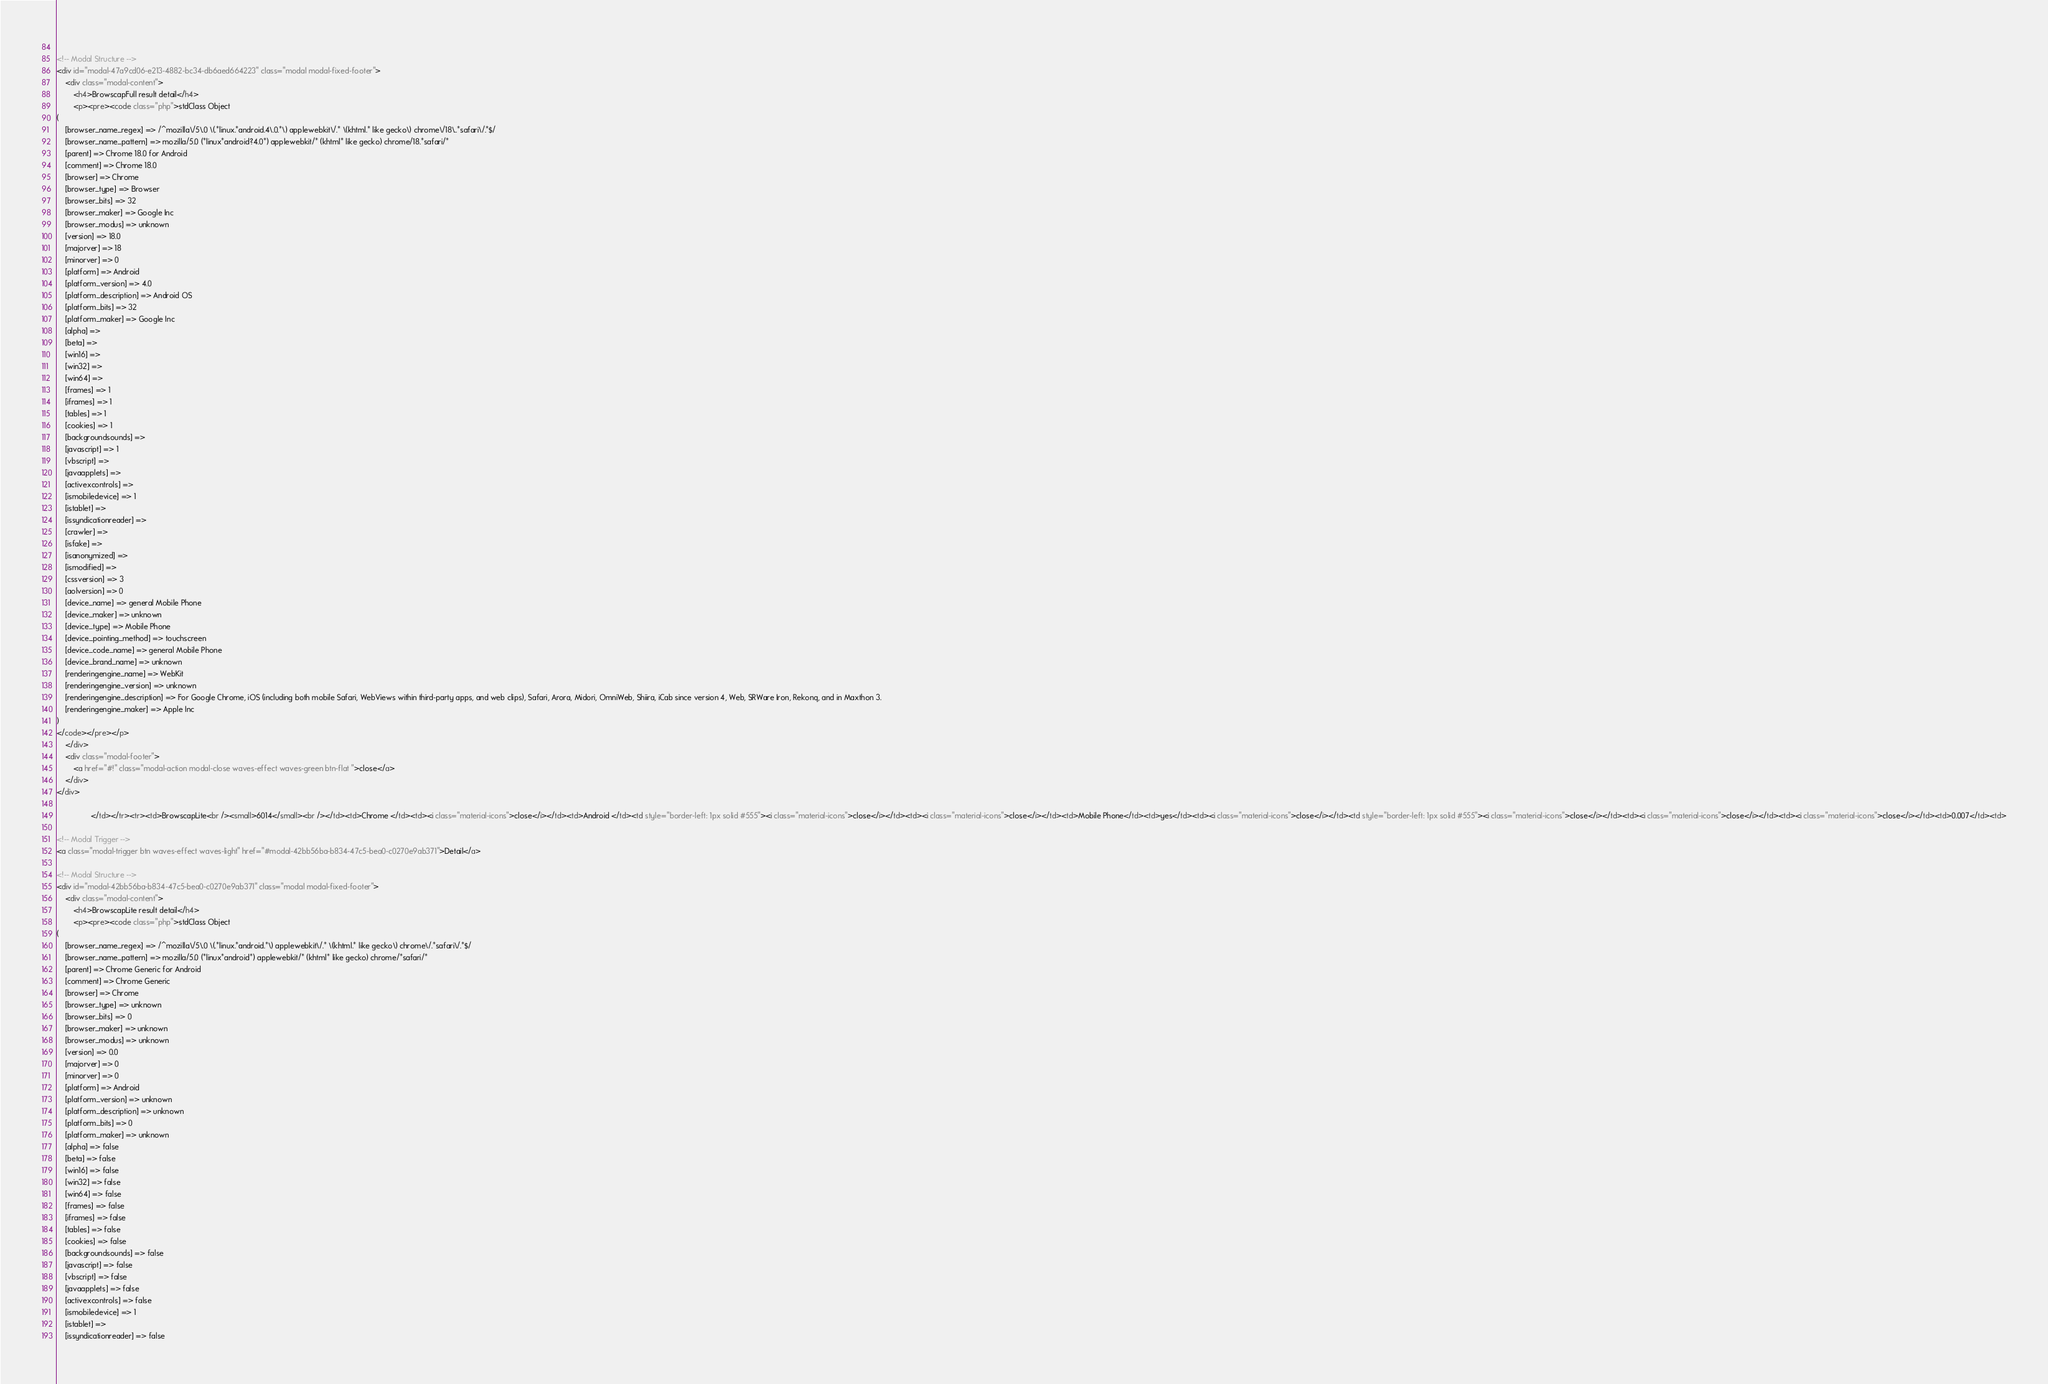<code> <loc_0><loc_0><loc_500><loc_500><_HTML_>        
<!-- Modal Structure -->
<div id="modal-47a9cd06-e213-4882-bc34-db6aed664223" class="modal modal-fixed-footer">
    <div class="modal-content">
        <h4>BrowscapFull result detail</h4>
        <p><pre><code class="php">stdClass Object
(
    [browser_name_regex] => /^mozilla\/5\.0 \(.*linux.*android.4\.0.*\) applewebkit\/.* \(khtml.* like gecko\) chrome\/18\..*safari\/.*$/
    [browser_name_pattern] => mozilla/5.0 (*linux*android?4.0*) applewebkit/* (khtml* like gecko) chrome/18.*safari/*
    [parent] => Chrome 18.0 for Android
    [comment] => Chrome 18.0
    [browser] => Chrome
    [browser_type] => Browser
    [browser_bits] => 32
    [browser_maker] => Google Inc
    [browser_modus] => unknown
    [version] => 18.0
    [majorver] => 18
    [minorver] => 0
    [platform] => Android
    [platform_version] => 4.0
    [platform_description] => Android OS
    [platform_bits] => 32
    [platform_maker] => Google Inc
    [alpha] => 
    [beta] => 
    [win16] => 
    [win32] => 
    [win64] => 
    [frames] => 1
    [iframes] => 1
    [tables] => 1
    [cookies] => 1
    [backgroundsounds] => 
    [javascript] => 1
    [vbscript] => 
    [javaapplets] => 
    [activexcontrols] => 
    [ismobiledevice] => 1
    [istablet] => 
    [issyndicationreader] => 
    [crawler] => 
    [isfake] => 
    [isanonymized] => 
    [ismodified] => 
    [cssversion] => 3
    [aolversion] => 0
    [device_name] => general Mobile Phone
    [device_maker] => unknown
    [device_type] => Mobile Phone
    [device_pointing_method] => touchscreen
    [device_code_name] => general Mobile Phone
    [device_brand_name] => unknown
    [renderingengine_name] => WebKit
    [renderingengine_version] => unknown
    [renderingengine_description] => For Google Chrome, iOS (including both mobile Safari, WebViews within third-party apps, and web clips), Safari, Arora, Midori, OmniWeb, Shiira, iCab since version 4, Web, SRWare Iron, Rekonq, and in Maxthon 3.
    [renderingengine_maker] => Apple Inc
)
</code></pre></p>
    </div>
    <div class="modal-footer">
        <a href="#!" class="modal-action modal-close waves-effect waves-green btn-flat ">close</a>
    </div>
</div>
        
                </td></tr><tr><td>BrowscapLite<br /><small>6014</small><br /></td><td>Chrome </td><td><i class="material-icons">close</i></td><td>Android </td><td style="border-left: 1px solid #555"><i class="material-icons">close</i></td><td><i class="material-icons">close</i></td><td>Mobile Phone</td><td>yes</td><td><i class="material-icons">close</i></td><td style="border-left: 1px solid #555"><i class="material-icons">close</i></td><td><i class="material-icons">close</i></td><td><i class="material-icons">close</i></td><td>0.007</td><td>
        
<!-- Modal Trigger -->
<a class="modal-trigger btn waves-effect waves-light" href="#modal-42bb56ba-b834-47c5-bea0-c0270e9ab371">Detail</a>
        
<!-- Modal Structure -->
<div id="modal-42bb56ba-b834-47c5-bea0-c0270e9ab371" class="modal modal-fixed-footer">
    <div class="modal-content">
        <h4>BrowscapLite result detail</h4>
        <p><pre><code class="php">stdClass Object
(
    [browser_name_regex] => /^mozilla\/5\.0 \(.*linux.*android.*\) applewebkit\/.* \(khtml.* like gecko\) chrome\/.*safari\/.*$/
    [browser_name_pattern] => mozilla/5.0 (*linux*android*) applewebkit/* (khtml* like gecko) chrome/*safari/*
    [parent] => Chrome Generic for Android
    [comment] => Chrome Generic
    [browser] => Chrome
    [browser_type] => unknown
    [browser_bits] => 0
    [browser_maker] => unknown
    [browser_modus] => unknown
    [version] => 0.0
    [majorver] => 0
    [minorver] => 0
    [platform] => Android
    [platform_version] => unknown
    [platform_description] => unknown
    [platform_bits] => 0
    [platform_maker] => unknown
    [alpha] => false
    [beta] => false
    [win16] => false
    [win32] => false
    [win64] => false
    [frames] => false
    [iframes] => false
    [tables] => false
    [cookies] => false
    [backgroundsounds] => false
    [javascript] => false
    [vbscript] => false
    [javaapplets] => false
    [activexcontrols] => false
    [ismobiledevice] => 1
    [istablet] => 
    [issyndicationreader] => false</code> 